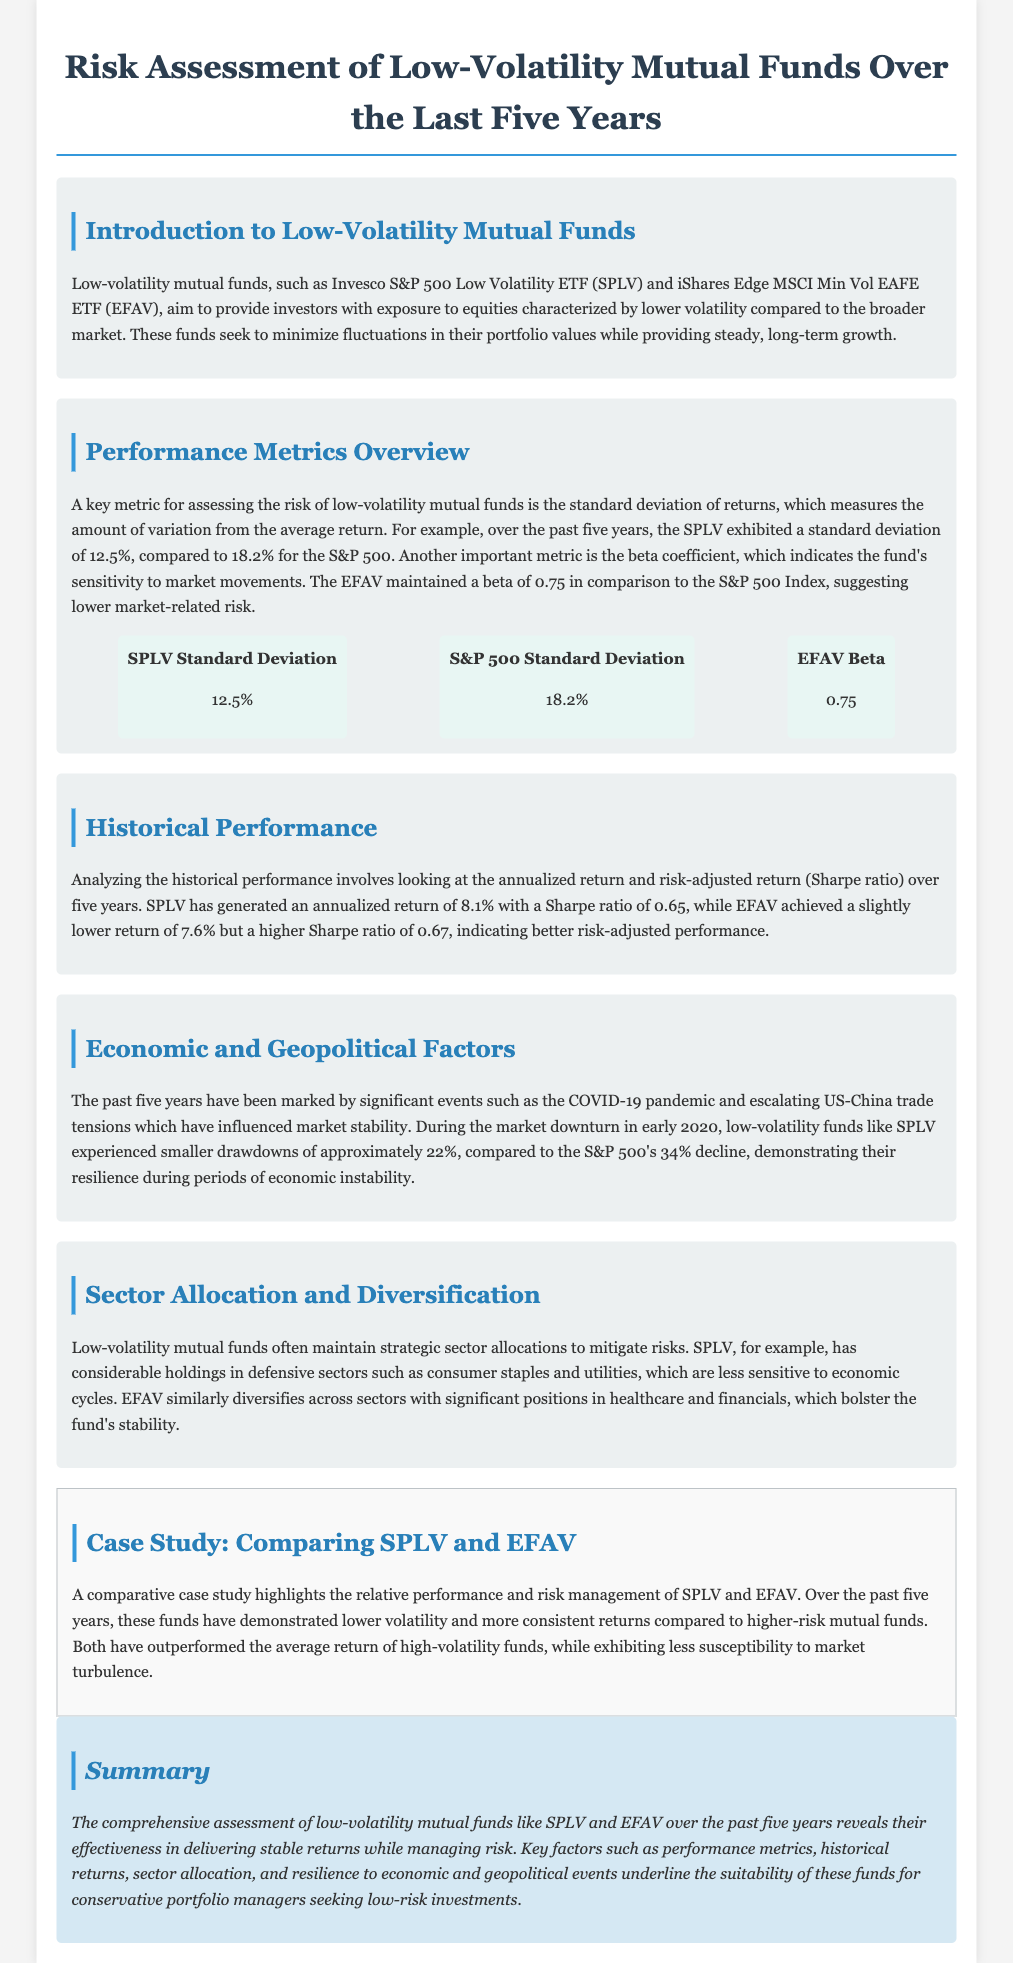what is the standard deviation of SPLV? The standard deviation of SPLV is provided in the performance metrics overview section, indicating its risk measurement over the past five years.
Answer: 12.5% what is the beta coefficient of EFAV? The beta coefficient is specified in the performance metrics overview section, which measures the fund's sensitivity to market movements.
Answer: 0.75 what was the annualized return of SPLV? The annualized return for SPLV is noted in the historical performance section, highlighting its performance over five years.
Answer: 8.1% how much did SPLV decline during the market downturn in early 2020? The decline during the market downturn is mentioned in the economic and geopolitical factors section, comparing it to the S&P 500's performance.
Answer: approximately 22% which sectors does SPLV have considerable holdings in? The sectors where SPLV has significant holdings are detailed in the sector allocation and diversification section, indicating its strategy for risk mitigation.
Answer: consumer staples and utilities which fund achieved a higher Sharpe ratio, SPLV or EFAV? The comparison of Sharpe ratios is included in the historical performance section, which evaluates risk-adjusted performance.
Answer: EFAV what are the names of the two low-volatility mutual funds discussed? The introduction to low-volatility mutual funds lists both funds, providing context for the assessment.
Answer: Invesco S&P 500 Low Volatility ETF and iShares Edge MSCI Min Vol EAFE ETF what is the significance of low-volatility mutual funds based on the summary? The summary outlines the effectiveness and risk management of these funds, underpinning their value to conservative investors.
Answer: delivering stable returns while managing risk 